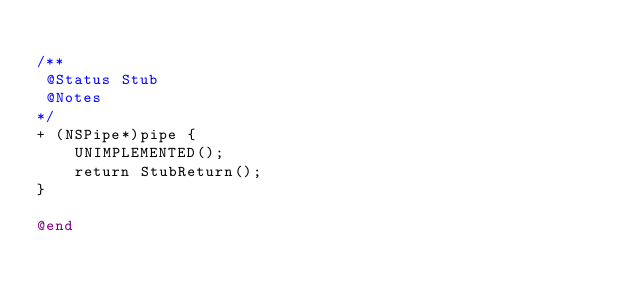Convert code to text. <code><loc_0><loc_0><loc_500><loc_500><_ObjectiveC_>
/**
 @Status Stub
 @Notes
*/
+ (NSPipe*)pipe {
    UNIMPLEMENTED();
    return StubReturn();
}

@end
</code> 